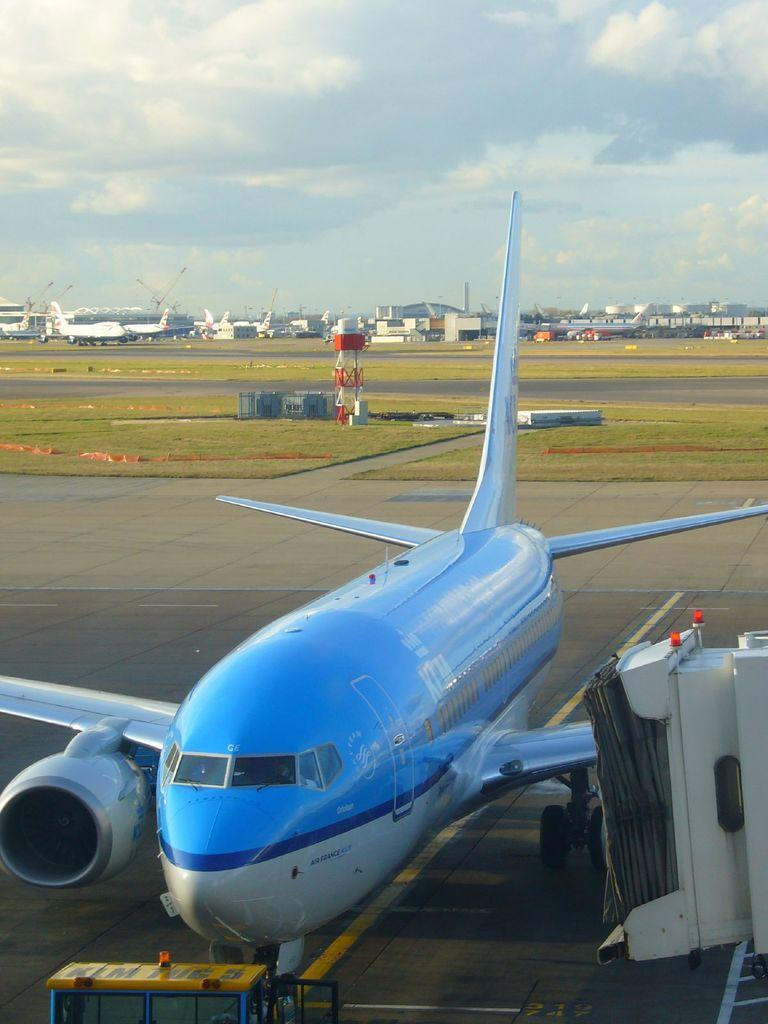What is the main subject of the image? The main subject of the image is aeroplanes. What can be seen in the background of the image? There are buildings and the sky visible in the background of the image. What is located at the bottom of the image? There is a runway at the bottom of the image. What type of copper square can be seen in the image? There is no copper square present in the image. 